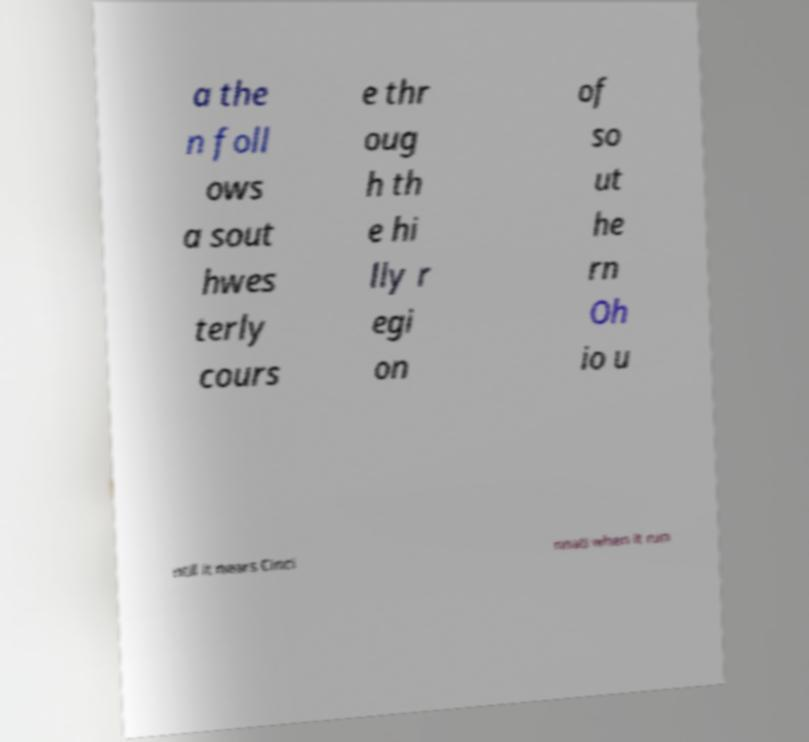Could you extract and type out the text from this image? a the n foll ows a sout hwes terly cours e thr oug h th e hi lly r egi on of so ut he rn Oh io u ntil it nears Cinci nnati when it run 